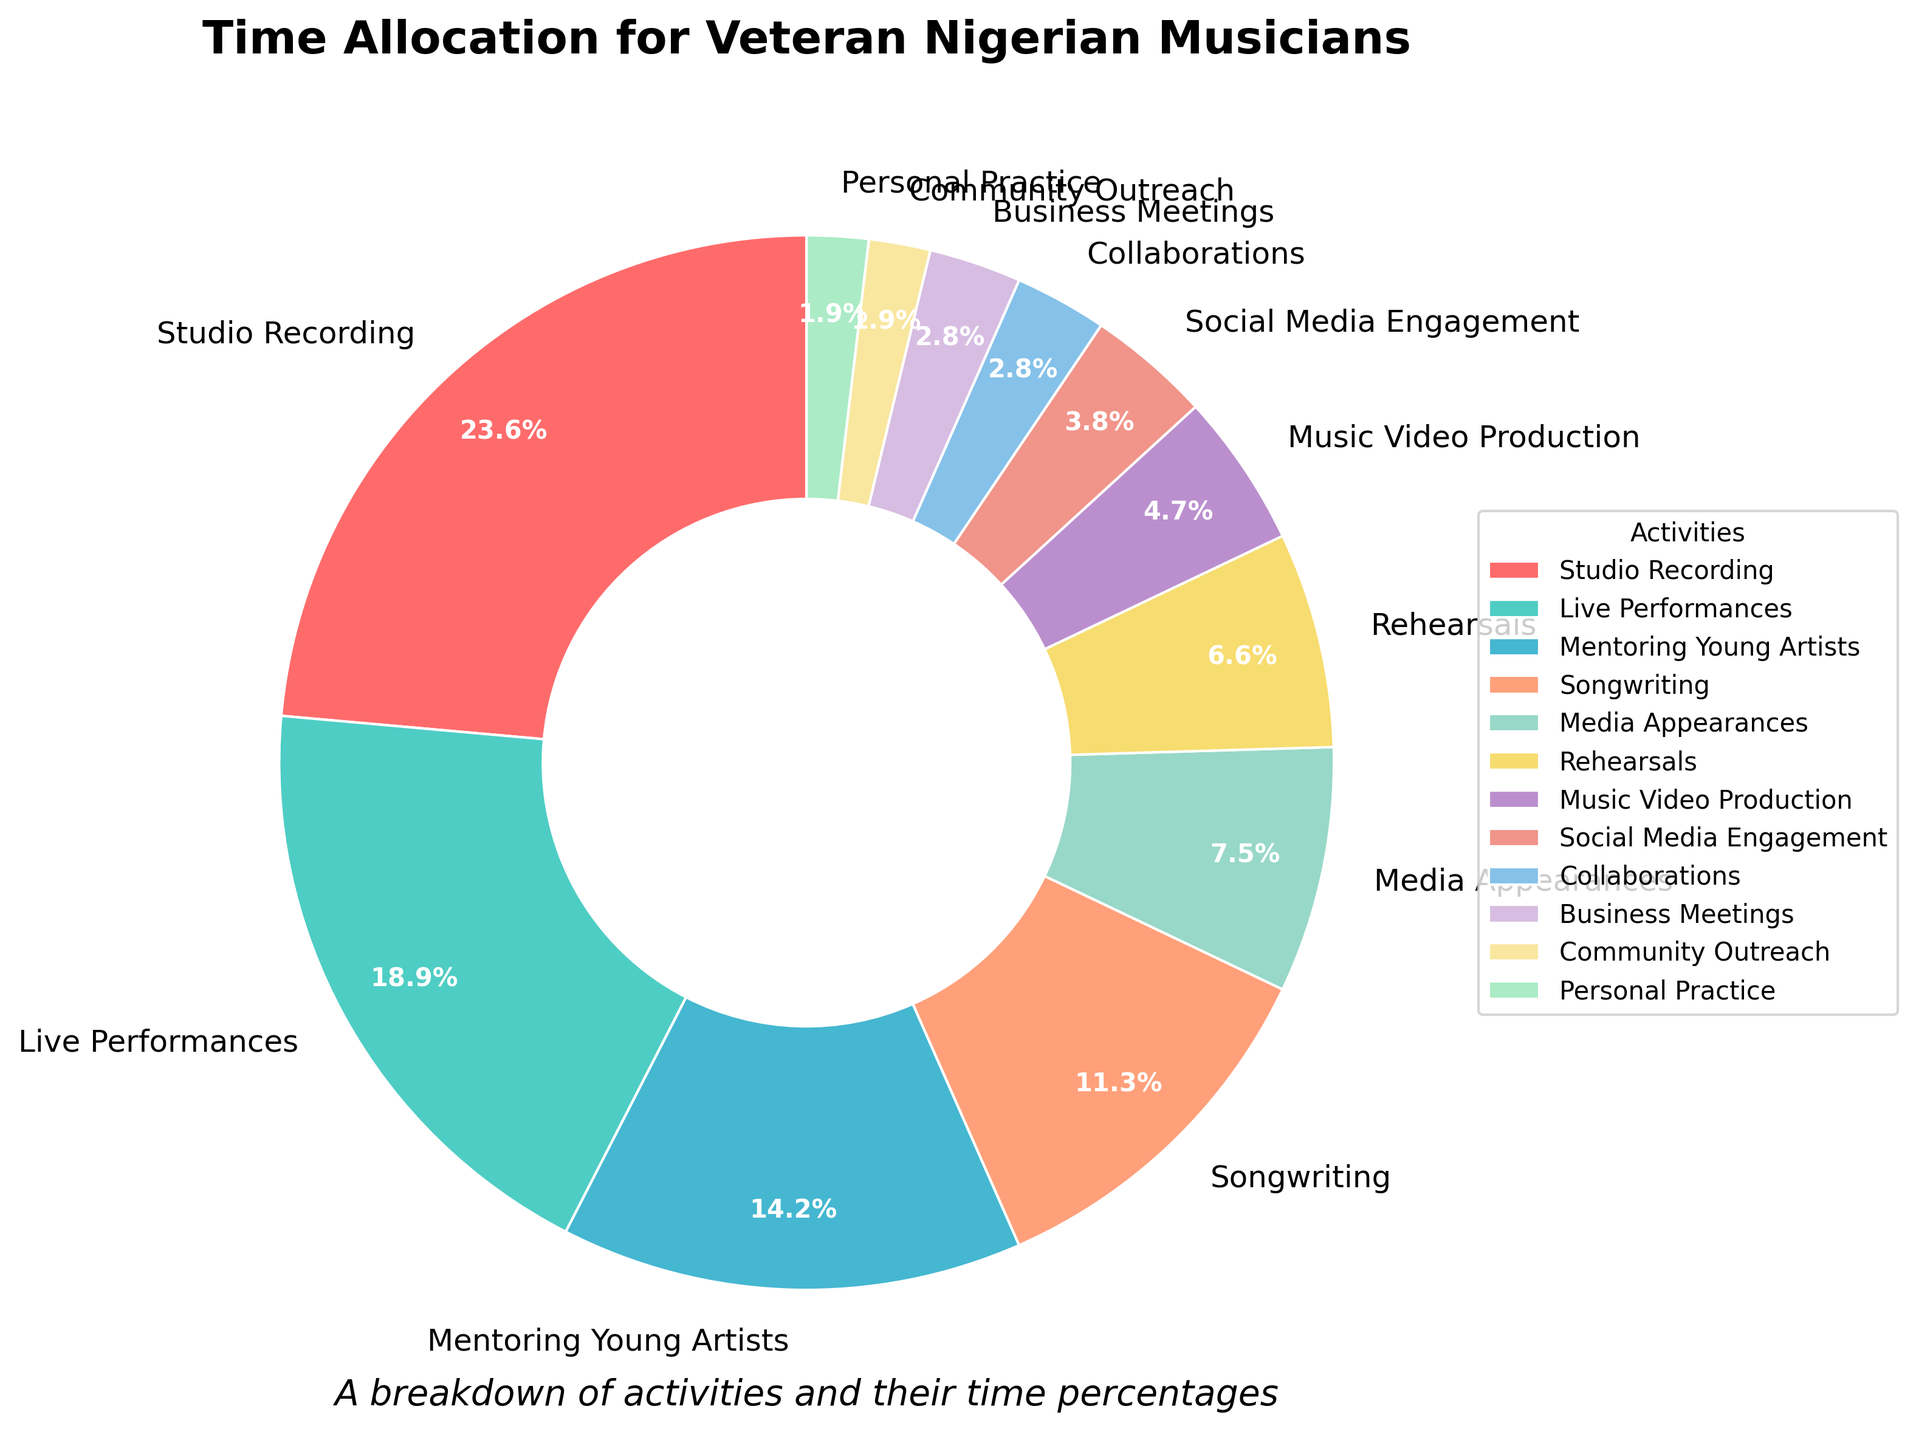What percentage of time is spent on studio recording? Look for the slice labeled "Studio Recording" in the pie chart and read the associated percentage.
Answer: 25% Which activity takes up more time: Media Appearances or Rehearsals? Identify the slices and their associated percentages for "Media Appearances" and "Rehearsals". Media Appearances is 8% and Rehearsals is 7%.
Answer: Media Appearances How much time in total is allocated to Mentoring Young Artists and Community Outreach? Find the percentages for "Mentoring Young Artists" and "Community Outreach". They are 15% and 2%, respectively. Adding these together gives 15% + 2% = 17%.
Answer: 17% What is the difference in time allocation between Live Performances and Songwriting? Look for the percentages of "Live Performances" and "Songwriting". Live Performances is 20% and Songwriting is 12%. Subtract 12% from 20% to get the difference.
Answer: 8% Which activity has the smallest percentage allocation, and what is it? Identify the slice with the smallest percentage which is labeled "Personal Practice".
Answer: Personal Practice, 2% How does the time spent on Music Video Production compare to that spent on Social Media Engagement? Check the slices for "Music Video Production" and "Social Media Engagement". Music Video Production is 5% while Social Media Engagement is 4%. So, Music Video Production takes up more time.
Answer: Music Video Production Is the time spent on Rehearsals greater than the time spent on Business Meetings? Identify the slices for "Rehearsals" (7%) and "Business Meetings" (3%), then compare the two values. Since 7% is greater than 3%, Rehearsals take up more time.
Answer: Yes What is the combined percentage of time allocated to activities that involve direct interaction with the public (Live Performances, Media Appearances, Community Outreach)? Add the percentages for "Live Performances" (20%), "Media Appearances" (8%), and "Community Outreach" (2%). 20% + 8% + 2% = 30%.
Answer: 30% Which activity category, Songwriting or Collaborations, receives a higher percentage of time allocation and by how much? Locate the percentages for "Songwriting" (12%) and "Collaborations" (3%). Subtract 3% from 12% to find the difference.
Answer: Songwriting, 9% If you combine the time spent on Personal Practice and Collaborations, is it still less than the time spent on Media Appearances? Sum the percentages for "Personal Practice" (2%) and "Collaborations" (3%) to get 5%. Compare this to the percentage for "Media Appearances" which is 8%. Since 5% is less than 8%, the combined time is still less.
Answer: Yes 